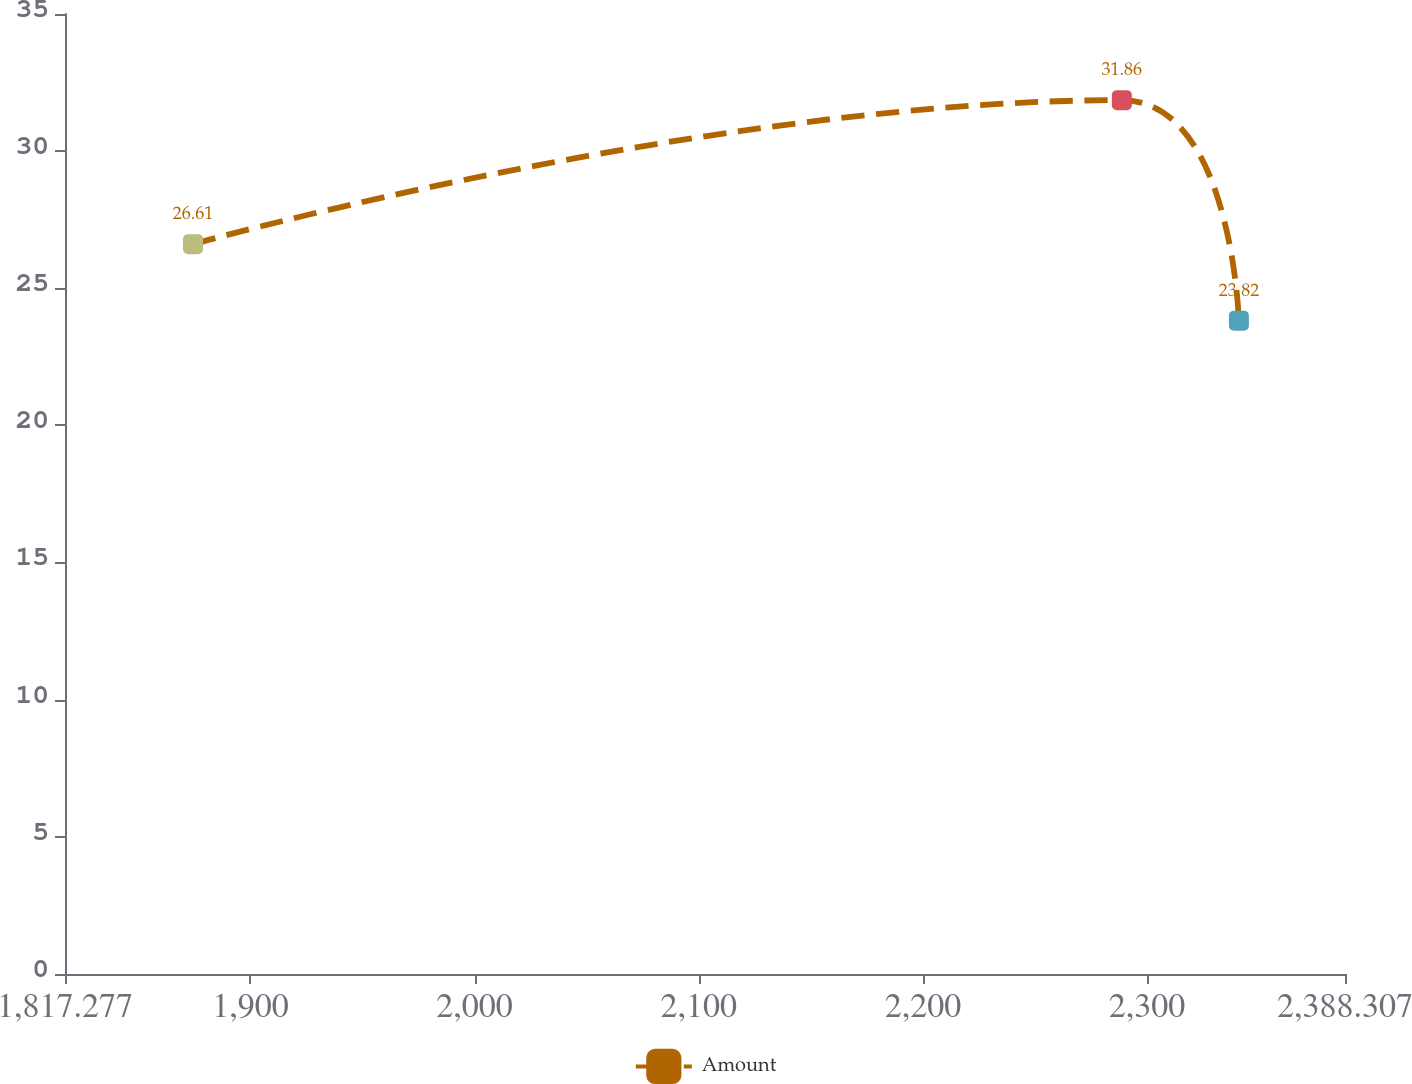Convert chart. <chart><loc_0><loc_0><loc_500><loc_500><line_chart><ecel><fcel>Amount<nl><fcel>1874.38<fcel>26.61<nl><fcel>2288.75<fcel>31.86<nl><fcel>2340.97<fcel>23.82<nl><fcel>2393.19<fcel>27.41<nl><fcel>2445.41<fcel>25.81<nl></chart> 